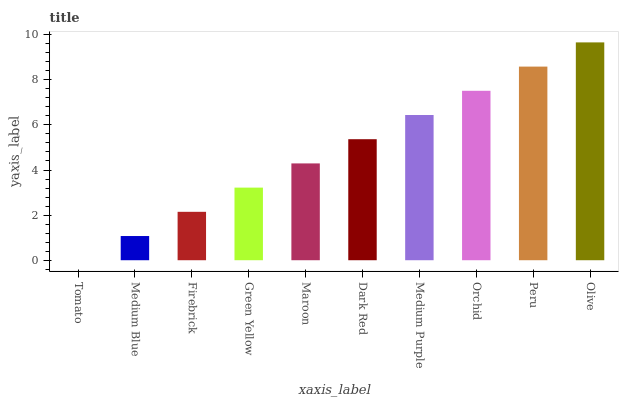Is Tomato the minimum?
Answer yes or no. Yes. Is Olive the maximum?
Answer yes or no. Yes. Is Medium Blue the minimum?
Answer yes or no. No. Is Medium Blue the maximum?
Answer yes or no. No. Is Medium Blue greater than Tomato?
Answer yes or no. Yes. Is Tomato less than Medium Blue?
Answer yes or no. Yes. Is Tomato greater than Medium Blue?
Answer yes or no. No. Is Medium Blue less than Tomato?
Answer yes or no. No. Is Dark Red the high median?
Answer yes or no. Yes. Is Maroon the low median?
Answer yes or no. Yes. Is Green Yellow the high median?
Answer yes or no. No. Is Medium Purple the low median?
Answer yes or no. No. 